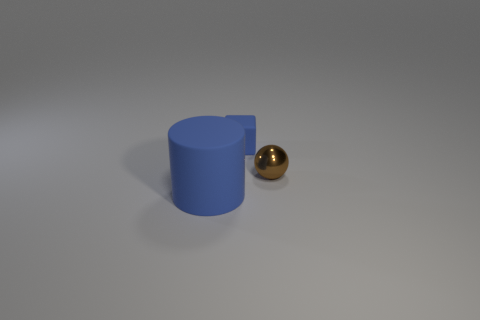There is a rubber cylinder that is the same color as the small matte block; what size is it?
Ensure brevity in your answer.  Large. There is a matte cylinder; is its size the same as the blue matte thing that is on the right side of the large blue rubber cylinder?
Your answer should be compact. No. What is the small sphere on the right side of the blue rubber thing in front of the tiny blue object made of?
Provide a short and direct response. Metal. There is a thing on the right side of the object behind the thing that is on the right side of the tiny blue block; what size is it?
Provide a succinct answer. Small. There is a shiny thing; does it have the same shape as the thing in front of the metallic ball?
Provide a succinct answer. No. What is the small blue block made of?
Give a very brief answer. Rubber. How many matte things are big cylinders or big brown things?
Your answer should be very brief. 1. Are there fewer tiny blue matte blocks in front of the matte cylinder than matte objects on the left side of the small blue rubber block?
Your response must be concise. Yes. There is a blue rubber thing left of the blue object that is behind the brown shiny object; are there any big blue cylinders that are behind it?
Offer a terse response. No. What is the material of the thing that is the same color as the matte cube?
Your answer should be very brief. Rubber. 